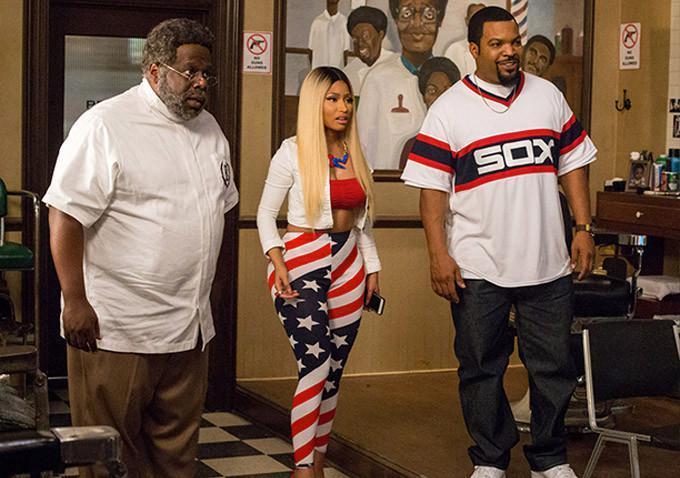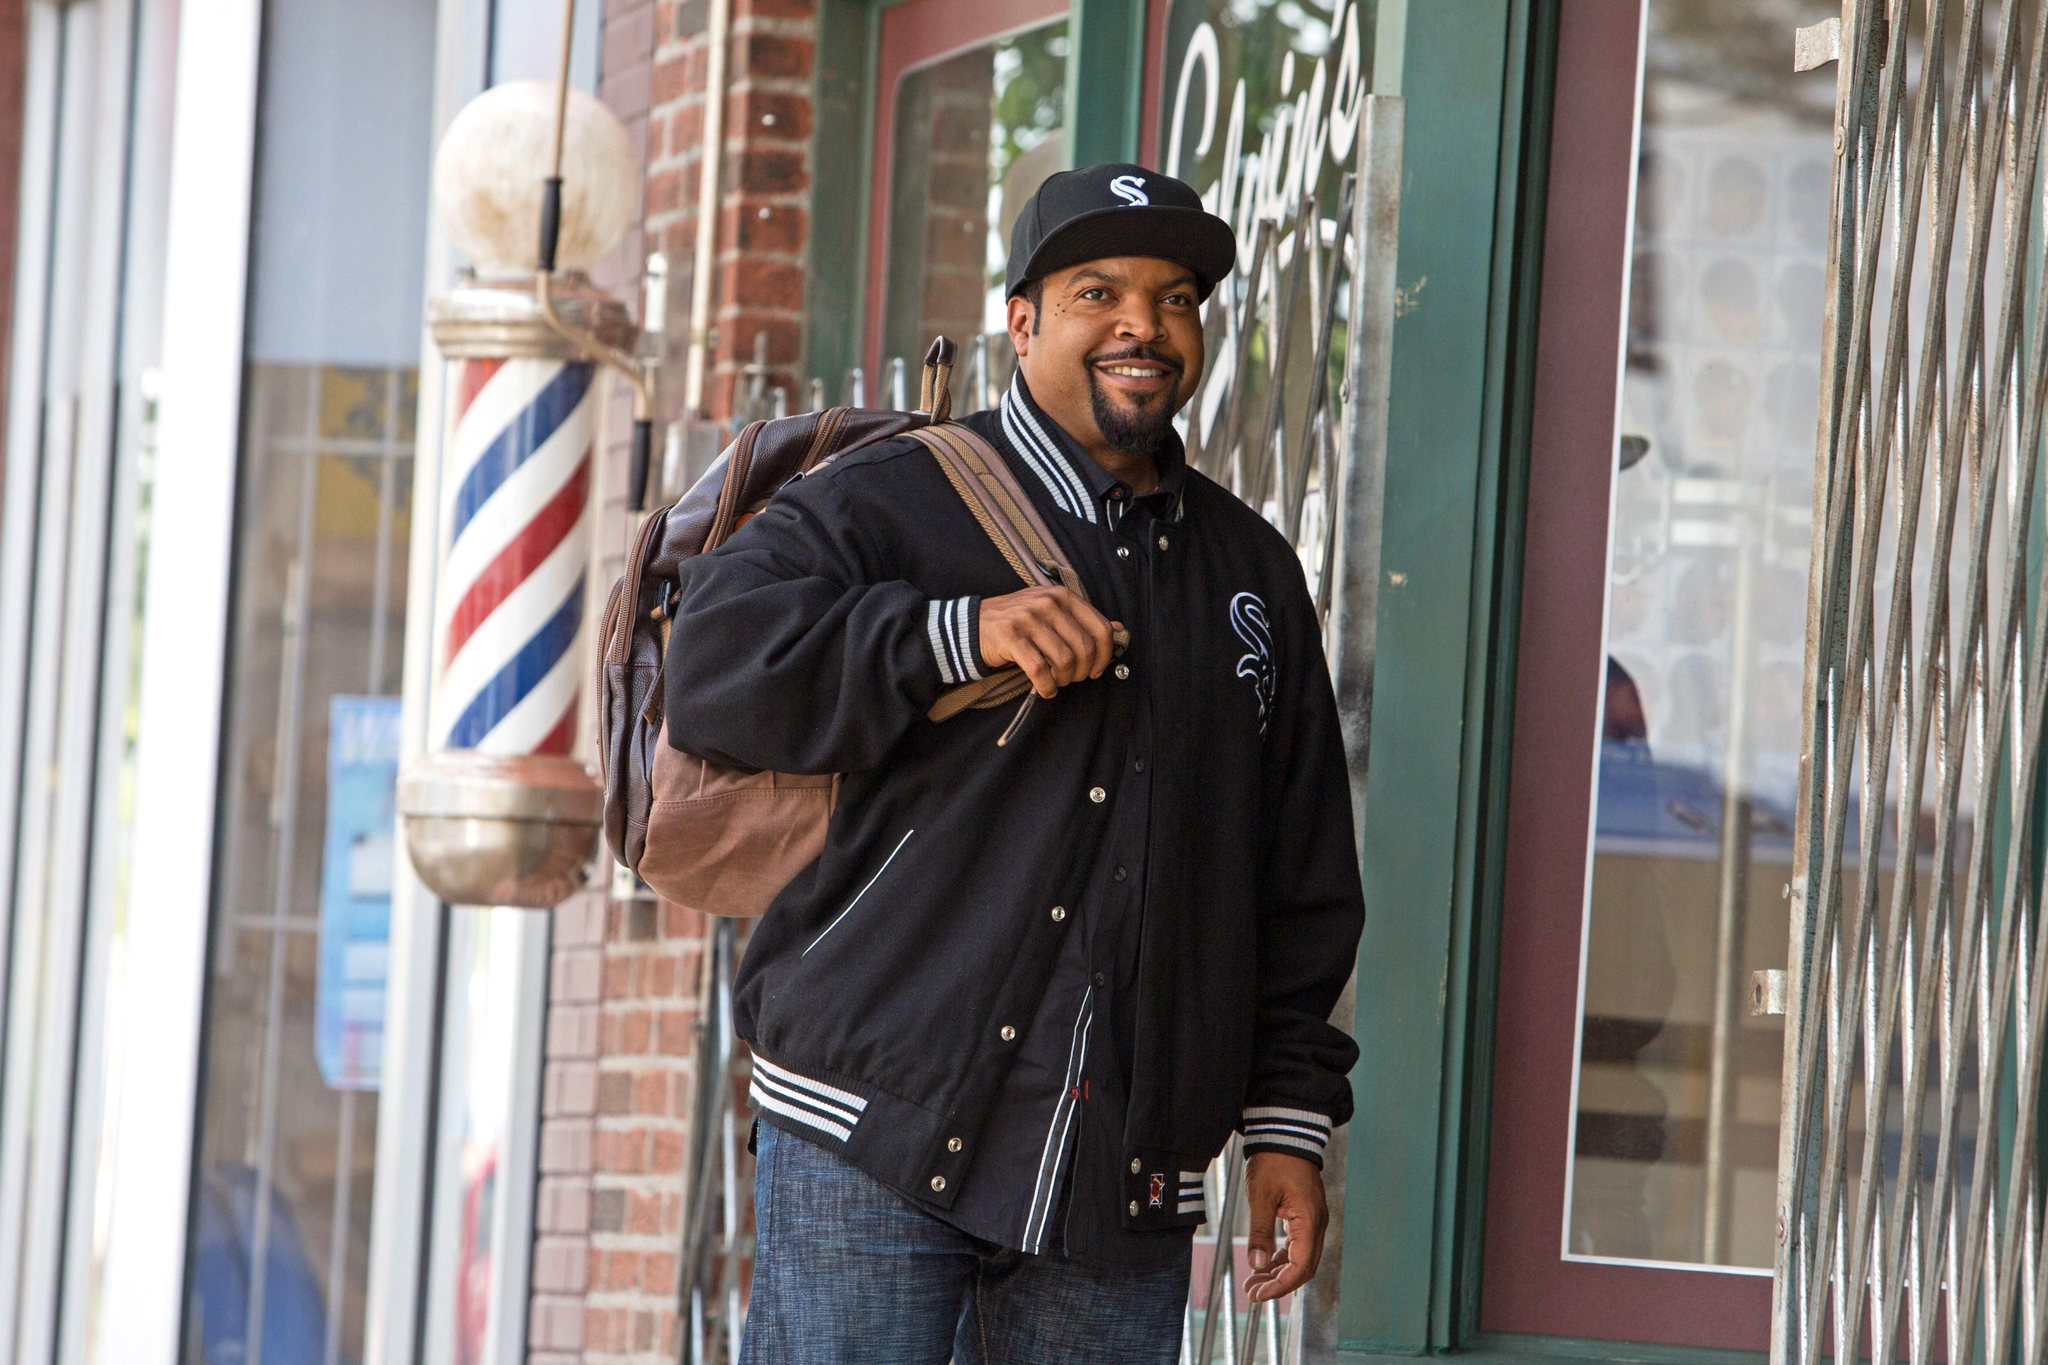The first image is the image on the left, the second image is the image on the right. For the images displayed, is the sentence "In one image, a child is draped in a barber's cape and getting a haircut" factually correct? Answer yes or no. No. The first image is the image on the left, the second image is the image on the right. Considering the images on both sides, is "An image shows at least one person standing by an outdoor barber pole." valid? Answer yes or no. Yes. The first image is the image on the left, the second image is the image on the right. Analyze the images presented: Is the assertion "The image on the right has no more than one person wearing a hat." valid? Answer yes or no. Yes. The first image is the image on the left, the second image is the image on the right. Given the left and right images, does the statement "In one of the images, a man stands alone with no one else present." hold true? Answer yes or no. Yes. 